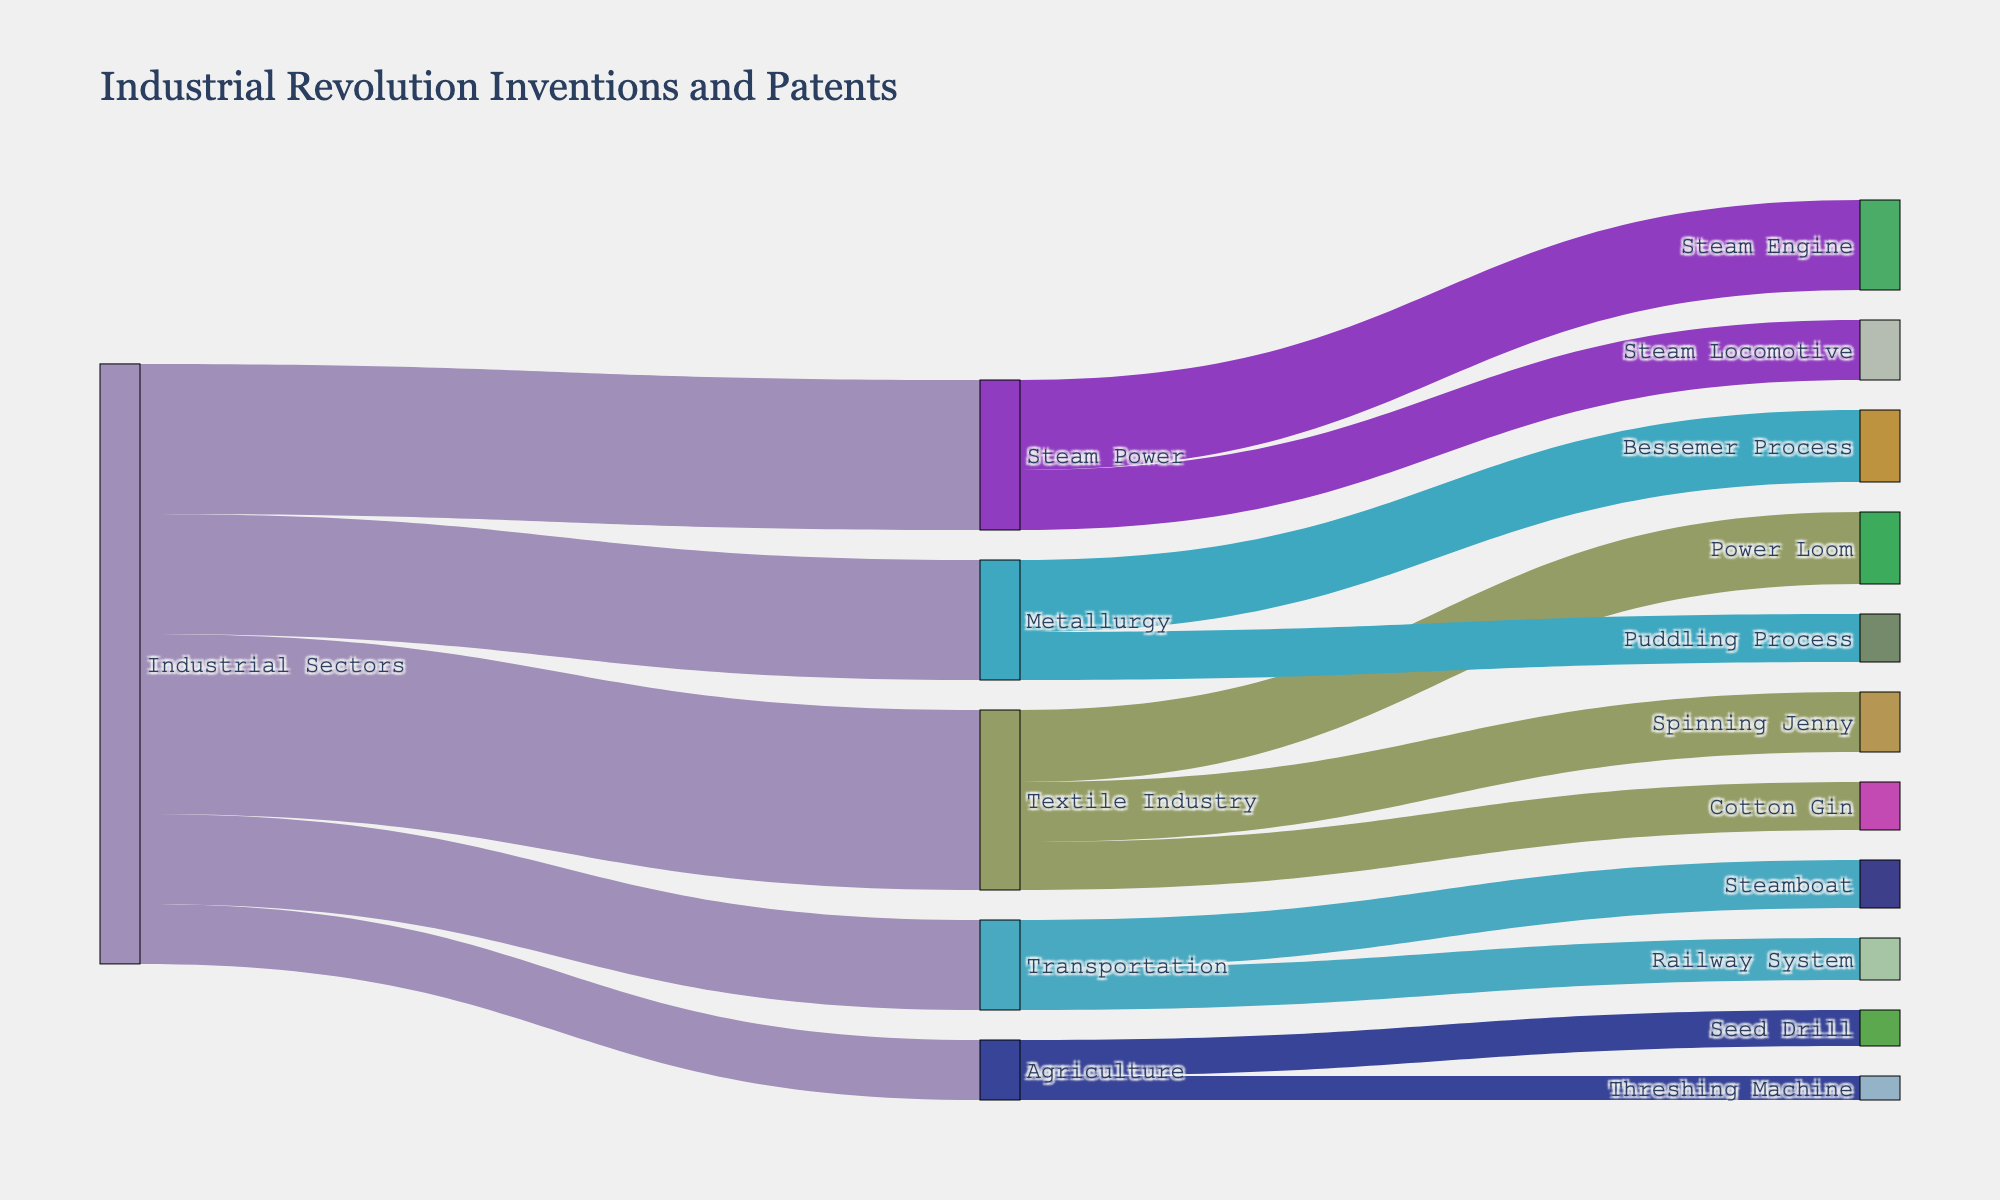what is the title of the figure? The title of the figure is written at the top of the diagram. It will tell us what the Sankey Diagram is about.
Answer: "Industrial Revolution Inventions and Patents" How many inventions are listed under the Textile Industry sector? To answer this, look at the number of branches coming out of the "Textile Industry" in the Sankey Diagram. Each branch represents an invention.
Answer: 3 Which industrial sector has the least number of inventions listed? Examine the branches coming out of each industrial sector. The sector with the fewest branches has the least number of inventions.
Answer: Agriculture What is the total number of patents in the Transportation sector? Add the values of the "Steamboat" and "Railway System" connected to the "Transportation" sector.
Answer: 15 Which invention has the highest value in the diagram? Compare the values attached to each invention. The one with the highest number is the answer.
Answer: Steam Engine Between "Textile Industry" and "Steam Power", which sector has more patents? Add up the values for each invention under both "Textile Industry" and "Steam Power" sectors, then compare the totals.
Answer: Textile Industry What is the combined value of all the patents? Sum up all the values listed in the diagram to get the combined total.
Answer: 120 By how much does the value of patents in the "Steam Engine" invention exceed that in the "Bessemer Process"? Subtract the value of "Bessemer Process" from the value of "Steam Engine".
Answer: 3 Which invention within the Agriculture sector has fewer patents? Compare the values of "Seed Drill" and "Threshing Machine" under the Agriculture sector. The one with the smaller value is the answer.
Answer: Threshing Machine What is the average value of patents across all sectors? First, find the total number of sectors (5). Sum up the values from each sector, then divide by the total number of sectors for the average.
Answer: 20 